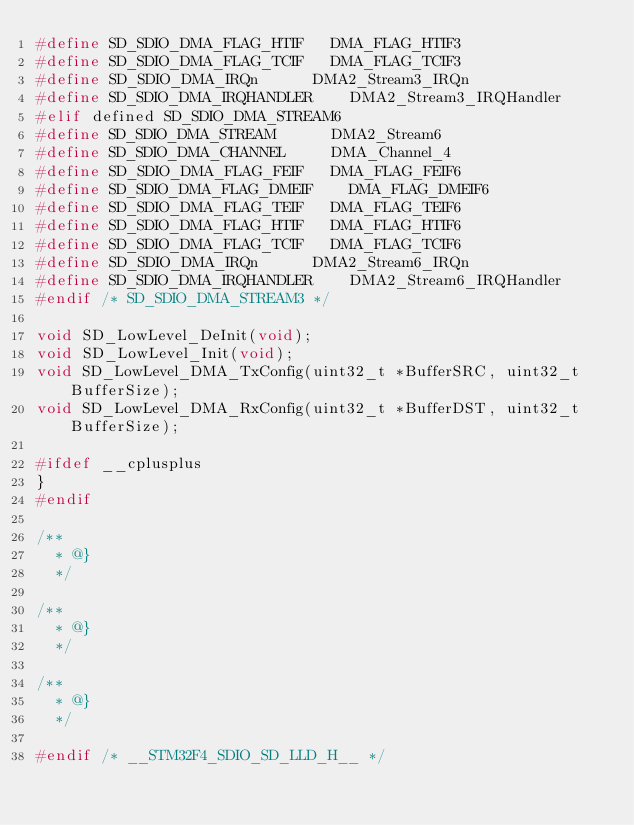Convert code to text. <code><loc_0><loc_0><loc_500><loc_500><_C_>#define SD_SDIO_DMA_FLAG_HTIF		DMA_FLAG_HTIF3
#define SD_SDIO_DMA_FLAG_TCIF		DMA_FLAG_TCIF3
#define SD_SDIO_DMA_IRQn			DMA2_Stream3_IRQn
#define SD_SDIO_DMA_IRQHANDLER		DMA2_Stream3_IRQHandler
#elif defined SD_SDIO_DMA_STREAM6
#define SD_SDIO_DMA_STREAM			DMA2_Stream6
#define SD_SDIO_DMA_CHANNEL			DMA_Channel_4
#define SD_SDIO_DMA_FLAG_FEIF		DMA_FLAG_FEIF6
#define SD_SDIO_DMA_FLAG_DMEIF		DMA_FLAG_DMEIF6
#define SD_SDIO_DMA_FLAG_TEIF		DMA_FLAG_TEIF6
#define SD_SDIO_DMA_FLAG_HTIF		DMA_FLAG_HTIF6
#define SD_SDIO_DMA_FLAG_TCIF		DMA_FLAG_TCIF6
#define SD_SDIO_DMA_IRQn			DMA2_Stream6_IRQn
#define SD_SDIO_DMA_IRQHANDLER		DMA2_Stream6_IRQHandler
#endif /* SD_SDIO_DMA_STREAM3 */

void SD_LowLevel_DeInit(void);
void SD_LowLevel_Init(void);
void SD_LowLevel_DMA_TxConfig(uint32_t *BufferSRC, uint32_t BufferSize);
void SD_LowLevel_DMA_RxConfig(uint32_t *BufferDST, uint32_t BufferSize);

#ifdef __cplusplus
}
#endif

/**
  * @}
  */

/**
  * @}
  */

/**
  * @}
  */

#endif /* __STM32F4_SDIO_SD_LLD_H__ */
</code> 